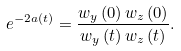Convert formula to latex. <formula><loc_0><loc_0><loc_500><loc_500>e ^ { - 2 a \left ( t \right ) } = \frac { w _ { y } \left ( 0 \right ) w _ { z } \left ( 0 \right ) } { w _ { y } \left ( t \right ) w _ { z } \left ( t \right ) } .</formula> 